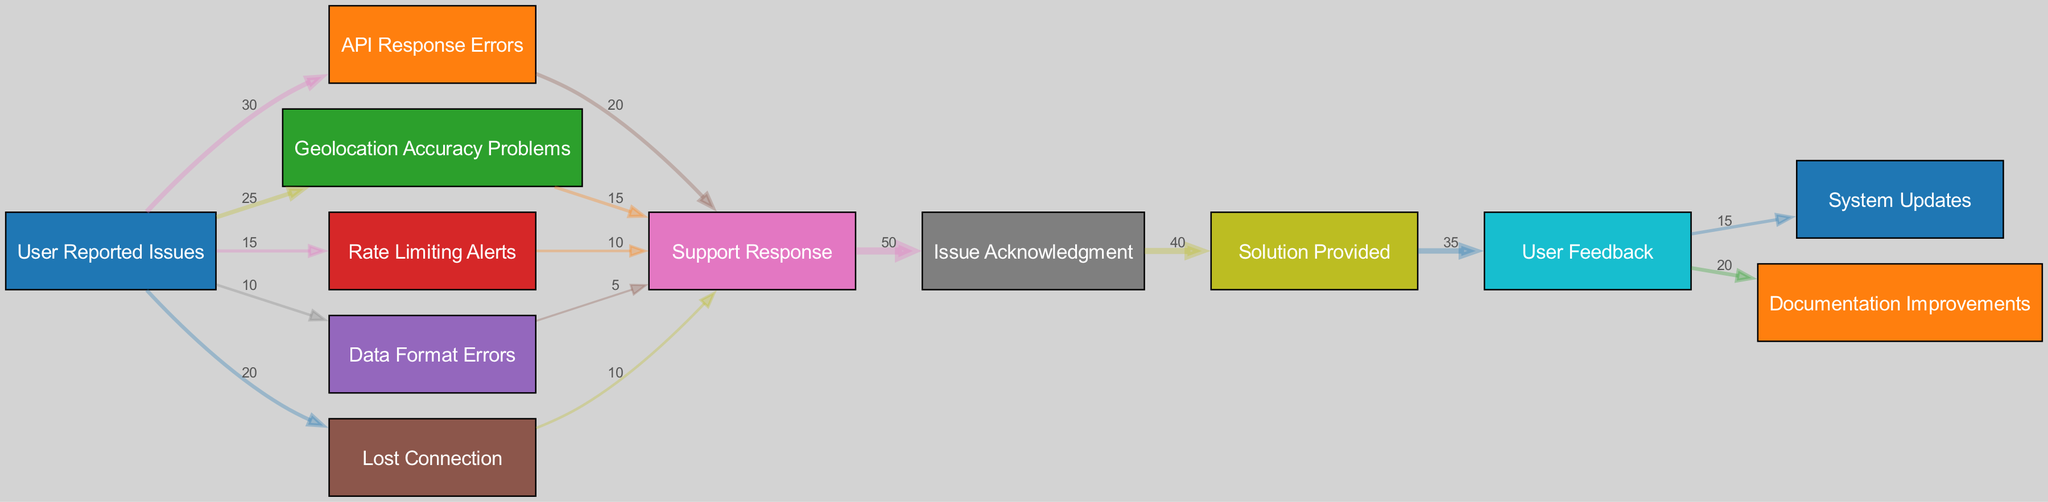What is the total number of user-reported issues? By adding the values associated with each user-reported issue from the diagram, we find that API Response Errors (30), Geolocation Accuracy Problems (25), Rate Limiting Alerts (15), Data Format Errors (10), and Lost Connection (20) total to 100 user-reported issues.
Answer: 100 Which user-reported issue has the highest value? The user-reported issue with the highest value is API Response Errors, which has a value of 30. This is evident from the visual representation where this issue is the thickest flow, indicating it is the most common problem reported by users.
Answer: API Response Errors How many nodes are there in total? By counting the number of distinct nodes listed in the diagram, we see that there are 12 unique nodes; these include user-reported issues, responses, acknowledgments, solutions, user feedback, and updates.
Answer: 12 What is the value of the connection between Geolocation Accuracy Problems and Support Response? The flow from Geolocation Accuracy Problems to Support Response has a value of 15, represented by the corresponding connection in the diagram.
Answer: 15 Which issue pathway has the least amount of reported connections? The Data Format Errors issue pathway has the least amount of reported connections, leading to Support Response with a value of 5, making it the weakest link in terms of user-reported issues.
Answer: Data Format Errors How many solutions were provided based on user feedback? The flow from Solution Provided to User Feedback has a value of 35, indicating that 35 solutions were provided that were directly influenced by user feedback.
Answer: 35 What percentage of support responses led to issue acknowledgment? The value from Support Response to Issue Acknowledgment is 50, and since there are 100 reported issues total, this represents 50 percent of support responses leading to issue acknowledgment.
Answer: 50 percent What is the relationship between User Feedback and System Updates? The connection between User Feedback and System Updates shows a value of 15, which indicates that 15 pieces of user feedback contributed to subsequent system updates, resulting in improvements.
Answer: 15 Which problem led to the most solutions based on user feedback? The user feedback that provided the most solutions resulted from Solution Provided, which also indicates that it is the key endpoint driven by user feedback, reflecting a successful resolution process.
Answer: Solution Provided 